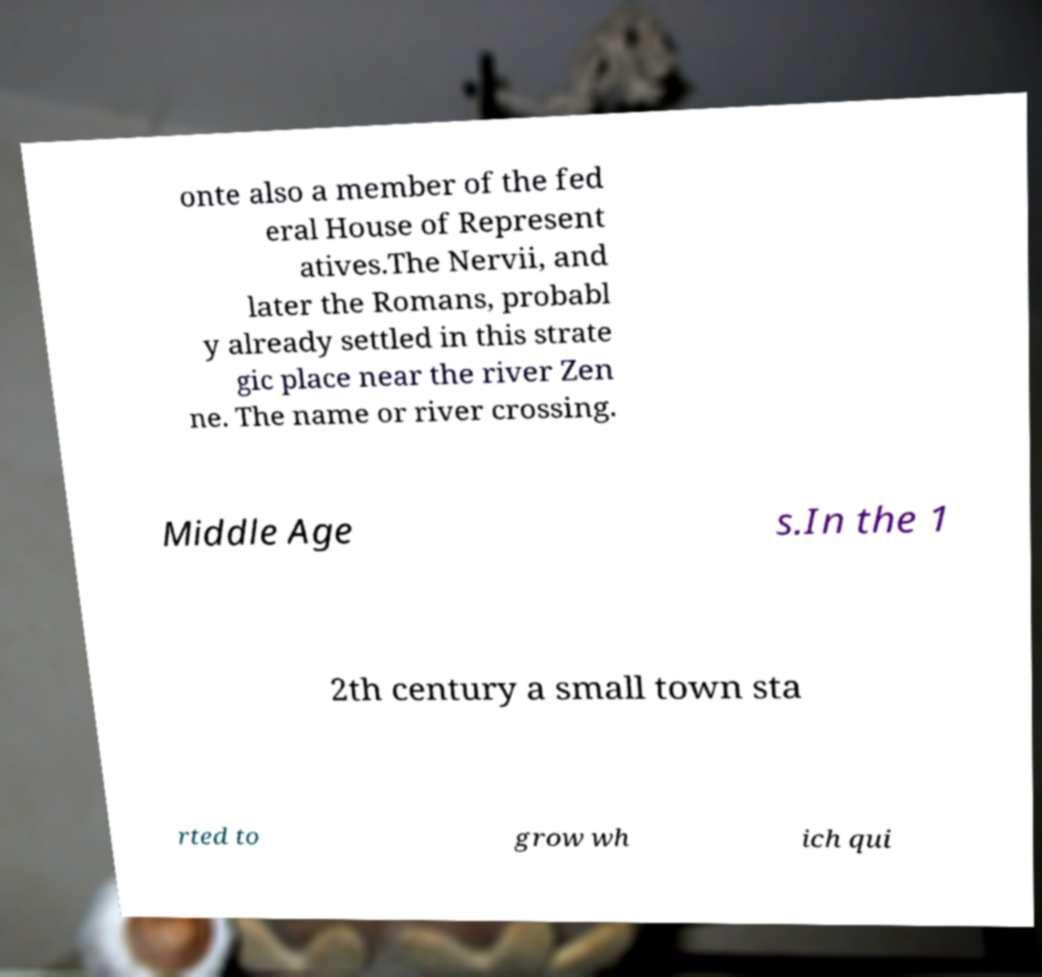Could you assist in decoding the text presented in this image and type it out clearly? onte also a member of the fed eral House of Represent atives.The Nervii, and later the Romans, probabl y already settled in this strate gic place near the river Zen ne. The name or river crossing. Middle Age s.In the 1 2th century a small town sta rted to grow wh ich qui 